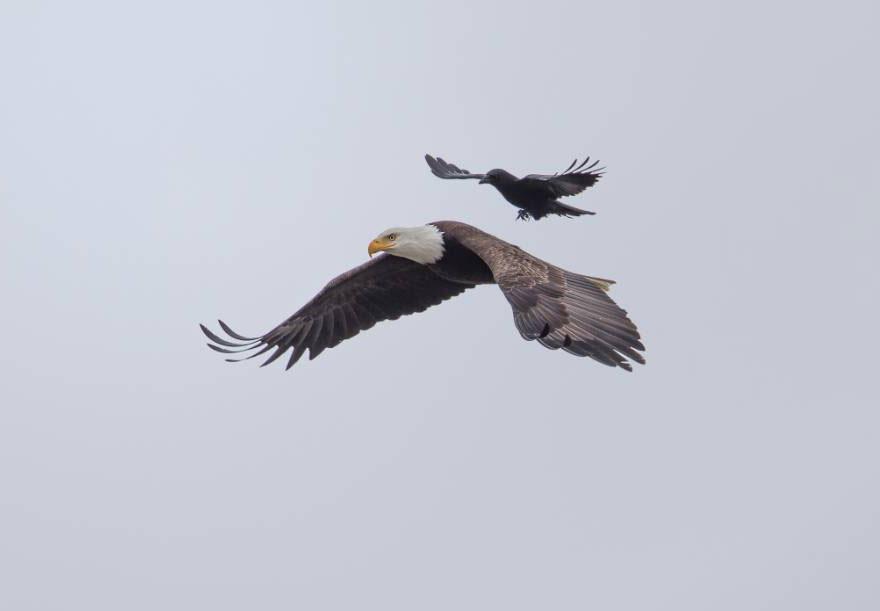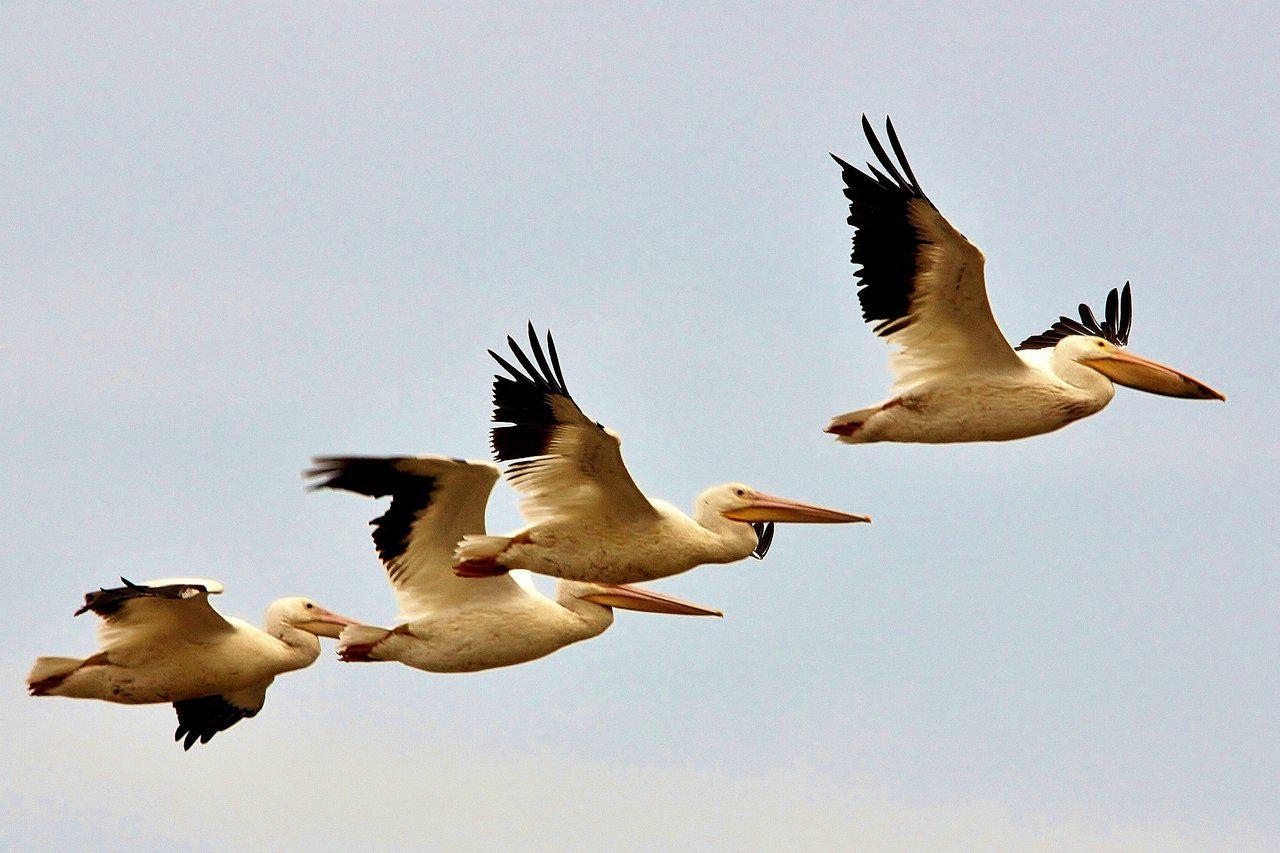The first image is the image on the left, the second image is the image on the right. Considering the images on both sides, is "Two birds are flying to the left in the image on the left." valid? Answer yes or no. Yes. The first image is the image on the left, the second image is the image on the right. Given the left and right images, does the statement "All of the birds in both images are flying rightward." hold true? Answer yes or no. No. 